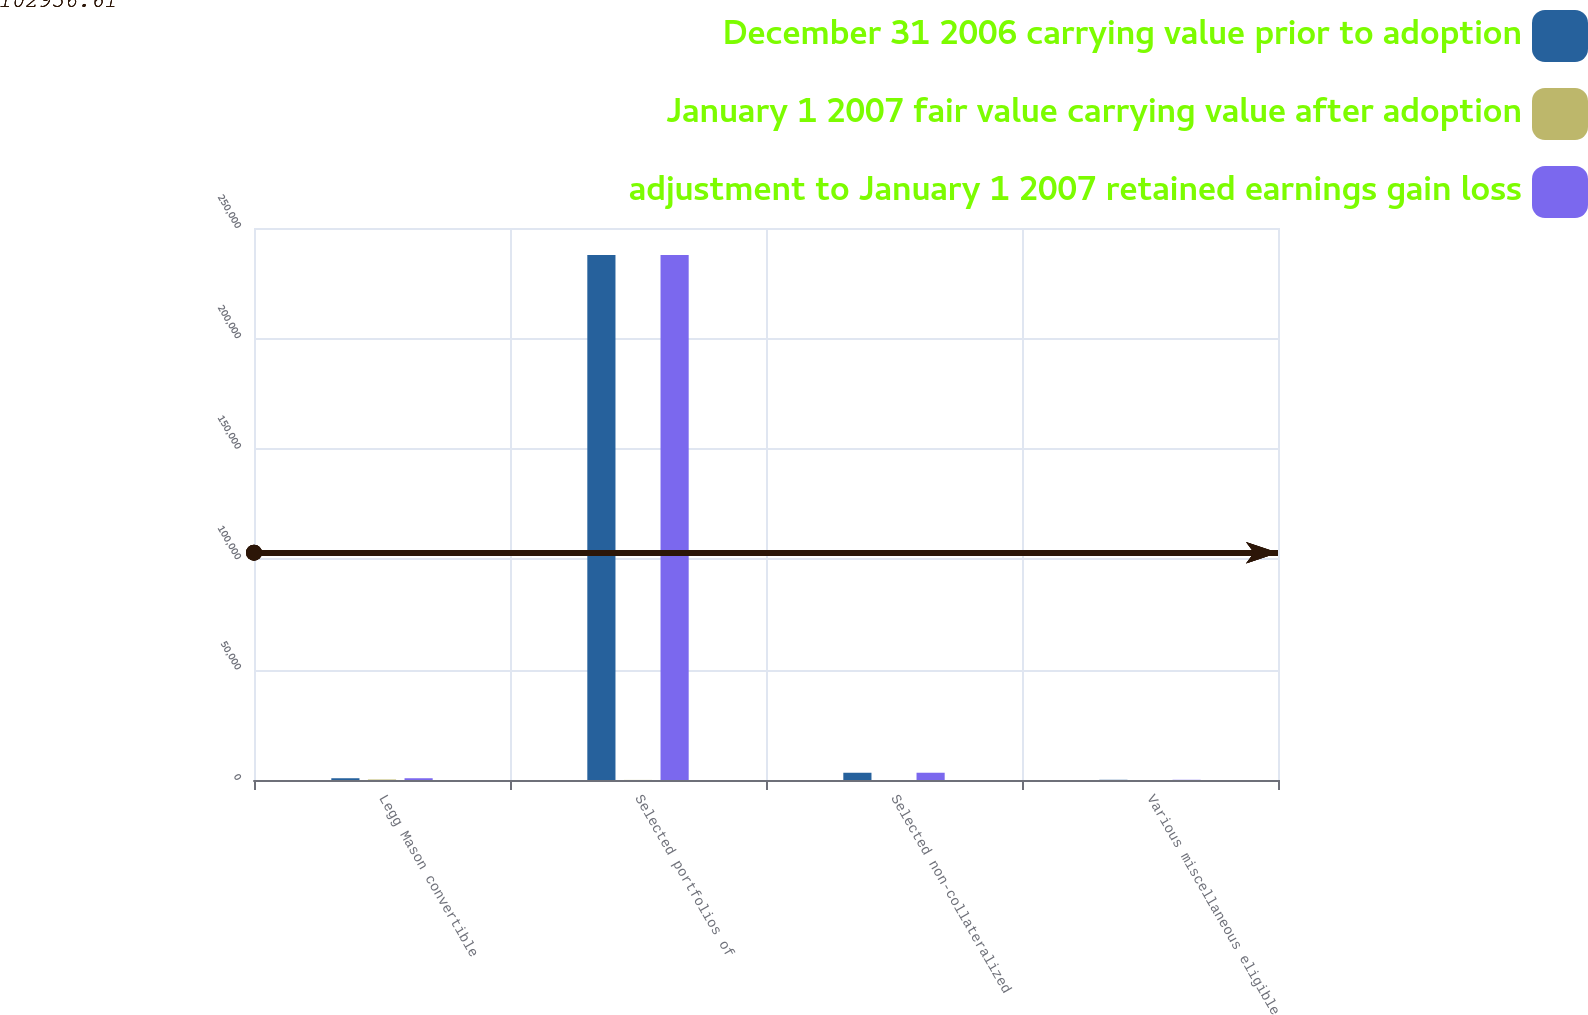Convert chart. <chart><loc_0><loc_0><loc_500><loc_500><stacked_bar_chart><ecel><fcel>Legg Mason convertible<fcel>Selected portfolios of<fcel>Selected non-collateralized<fcel>Various miscellaneous eligible<nl><fcel>December 31 2006 carrying value prior to adoption<fcel>797<fcel>237788<fcel>3284<fcel>96<nl><fcel>January 1 2007 fair value carrying value after adoption<fcel>232<fcel>40<fcel>7<fcel>3<nl><fcel>adjustment to January 1 2007 retained earnings gain loss<fcel>797<fcel>237748<fcel>3291<fcel>96<nl></chart> 